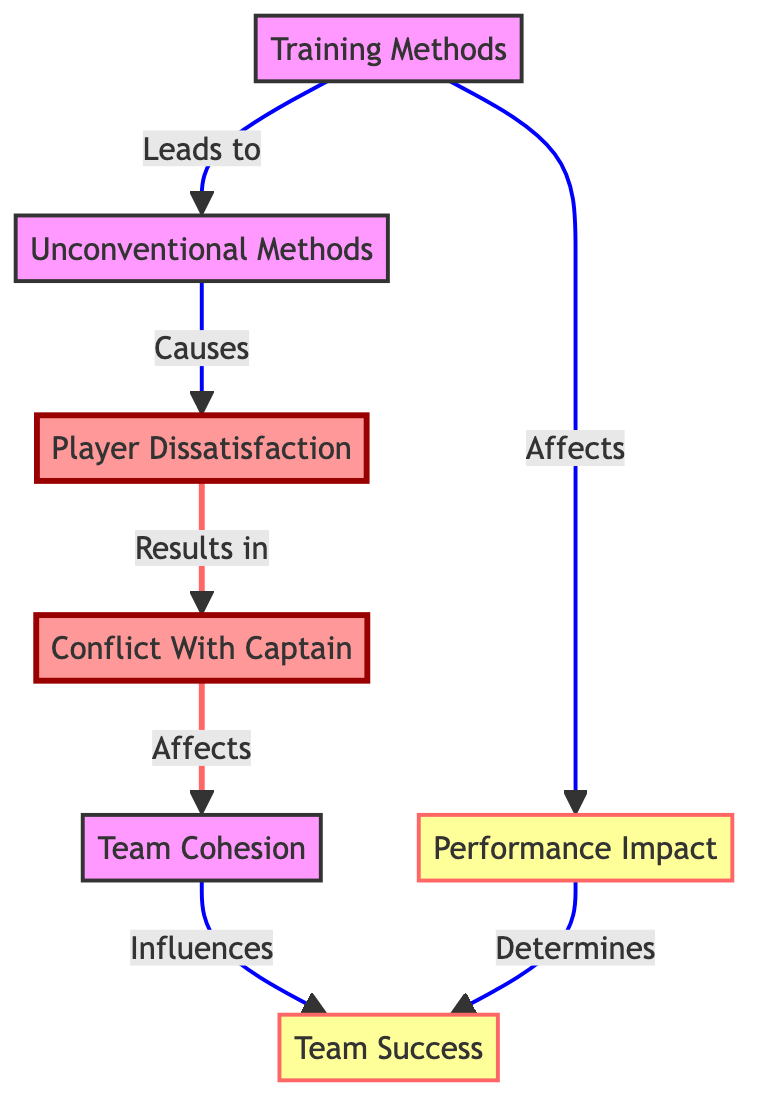What is the source node for Team Success? The directed graph shows that the Team Success node is influenced by both Team Cohesion and Performance Impact. However, in terms of immediate relationships, both nodes are direct outputs from other nodes in the diagram, and thus do not have a singular source but are influenced by the preceding nodes.
Answer: Team Cohesion and Performance Impact Which node represents issues faced by players? The diagram indicates Player Dissatisfaction as the node that represents player issues due to unconventional training methods. This node has a directed connection from Unconventional Methods, highlighting it as the source of dissatisfaction.
Answer: Player Dissatisfaction How many total nodes are in the diagram? To determine the total number of nodes, we count the unique nodes listed in the elements section of the diagram. There are seven distinct nodes.
Answer: Seven What causes player dissatisfaction? According to the relationships shown in the diagram, Player Dissatisfaction is directly caused by Unconventional Methods, which are a set of training approaches that lead to this dissatisfaction among players.
Answer: Unconventional Methods If Team Cohesion is negatively affected, what would be the impact? The directed graph indicates that if Team Cohesion is negatively affected, it will lead to a negative impact on Team Success. This relationship shows the importance of maintaining cohesion for overall team performance.
Answer: Team Success Which two nodes are connected by a conflict relationship? In the diagram, Player Dissatisfaction is connected to Conflict With Captain, indicating a clear relationship where dissatisfaction leads to conflicts over training methods. Thus, these two nodes form a conflict relationship.
Answer: Player Dissatisfaction and Conflict With Captain What are the two influences on Team Success? The directed graph reveals that Team Success is influenced by both Team Cohesion and Performance Impact, illustrating that success is dependent on both the unity of the team and the effectiveness of the training methods.
Answer: Team Cohesion and Performance Impact What influences have a direct effect on Training Methods? In the diagram, there are no influences that appear to directly affect Training Methods, as it serves as a starting point for the relationships to Unconventional Methods and Performance Impact. Thus, it is not influenced by any other node within the diagram.
Answer: None 